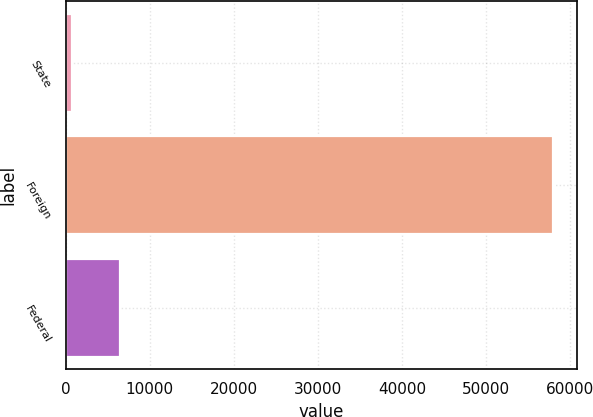Convert chart. <chart><loc_0><loc_0><loc_500><loc_500><bar_chart><fcel>State<fcel>Foreign<fcel>Federal<nl><fcel>797<fcel>57934<fcel>6510.7<nl></chart> 